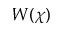<formula> <loc_0><loc_0><loc_500><loc_500>W ( \chi )</formula> 